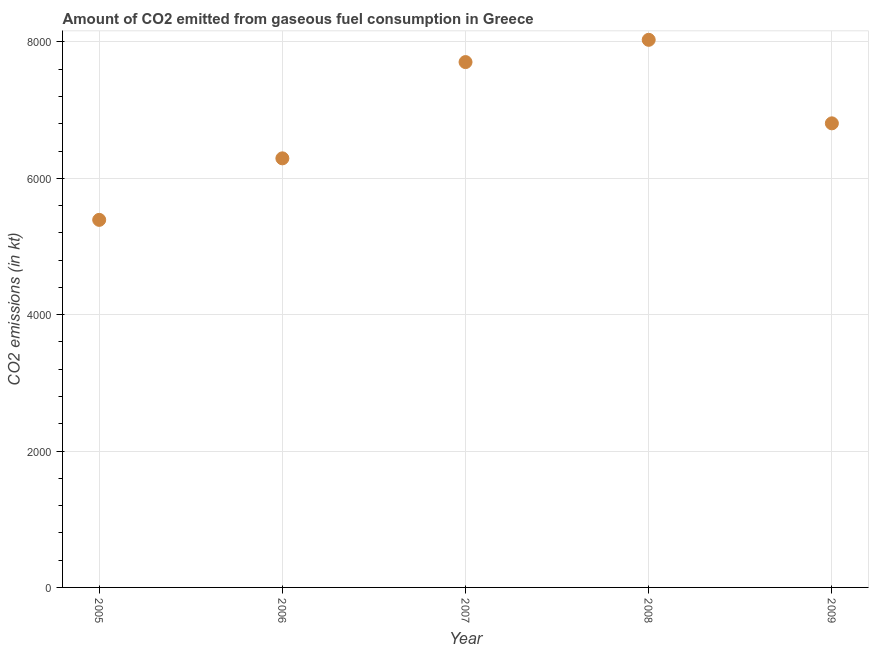What is the co2 emissions from gaseous fuel consumption in 2008?
Ensure brevity in your answer.  8030.73. Across all years, what is the maximum co2 emissions from gaseous fuel consumption?
Provide a short and direct response. 8030.73. Across all years, what is the minimum co2 emissions from gaseous fuel consumption?
Your response must be concise. 5390.49. In which year was the co2 emissions from gaseous fuel consumption maximum?
Offer a very short reply. 2008. What is the sum of the co2 emissions from gaseous fuel consumption?
Offer a terse response. 3.42e+04. What is the difference between the co2 emissions from gaseous fuel consumption in 2005 and 2006?
Provide a succinct answer. -902.08. What is the average co2 emissions from gaseous fuel consumption per year?
Offer a terse response. 6844.82. What is the median co2 emissions from gaseous fuel consumption?
Offer a very short reply. 6805.95. Do a majority of the years between 2007 and 2006 (inclusive) have co2 emissions from gaseous fuel consumption greater than 3600 kt?
Keep it short and to the point. No. What is the ratio of the co2 emissions from gaseous fuel consumption in 2006 to that in 2009?
Your answer should be very brief. 0.92. Is the co2 emissions from gaseous fuel consumption in 2007 less than that in 2009?
Offer a terse response. No. Is the difference between the co2 emissions from gaseous fuel consumption in 2005 and 2006 greater than the difference between any two years?
Offer a terse response. No. What is the difference between the highest and the second highest co2 emissions from gaseous fuel consumption?
Offer a very short reply. 326.36. Is the sum of the co2 emissions from gaseous fuel consumption in 2005 and 2007 greater than the maximum co2 emissions from gaseous fuel consumption across all years?
Keep it short and to the point. Yes. What is the difference between the highest and the lowest co2 emissions from gaseous fuel consumption?
Keep it short and to the point. 2640.24. Does the co2 emissions from gaseous fuel consumption monotonically increase over the years?
Keep it short and to the point. No. How many dotlines are there?
Offer a very short reply. 1. What is the difference between two consecutive major ticks on the Y-axis?
Offer a very short reply. 2000. Are the values on the major ticks of Y-axis written in scientific E-notation?
Provide a succinct answer. No. Does the graph contain grids?
Your answer should be compact. Yes. What is the title of the graph?
Keep it short and to the point. Amount of CO2 emitted from gaseous fuel consumption in Greece. What is the label or title of the X-axis?
Ensure brevity in your answer.  Year. What is the label or title of the Y-axis?
Your answer should be very brief. CO2 emissions (in kt). What is the CO2 emissions (in kt) in 2005?
Provide a short and direct response. 5390.49. What is the CO2 emissions (in kt) in 2006?
Offer a very short reply. 6292.57. What is the CO2 emissions (in kt) in 2007?
Provide a succinct answer. 7704.37. What is the CO2 emissions (in kt) in 2008?
Provide a succinct answer. 8030.73. What is the CO2 emissions (in kt) in 2009?
Offer a very short reply. 6805.95. What is the difference between the CO2 emissions (in kt) in 2005 and 2006?
Your answer should be compact. -902.08. What is the difference between the CO2 emissions (in kt) in 2005 and 2007?
Keep it short and to the point. -2313.88. What is the difference between the CO2 emissions (in kt) in 2005 and 2008?
Offer a terse response. -2640.24. What is the difference between the CO2 emissions (in kt) in 2005 and 2009?
Provide a short and direct response. -1415.46. What is the difference between the CO2 emissions (in kt) in 2006 and 2007?
Ensure brevity in your answer.  -1411.8. What is the difference between the CO2 emissions (in kt) in 2006 and 2008?
Your answer should be very brief. -1738.16. What is the difference between the CO2 emissions (in kt) in 2006 and 2009?
Offer a terse response. -513.38. What is the difference between the CO2 emissions (in kt) in 2007 and 2008?
Ensure brevity in your answer.  -326.36. What is the difference between the CO2 emissions (in kt) in 2007 and 2009?
Offer a very short reply. 898.41. What is the difference between the CO2 emissions (in kt) in 2008 and 2009?
Provide a succinct answer. 1224.78. What is the ratio of the CO2 emissions (in kt) in 2005 to that in 2006?
Make the answer very short. 0.86. What is the ratio of the CO2 emissions (in kt) in 2005 to that in 2007?
Ensure brevity in your answer.  0.7. What is the ratio of the CO2 emissions (in kt) in 2005 to that in 2008?
Offer a very short reply. 0.67. What is the ratio of the CO2 emissions (in kt) in 2005 to that in 2009?
Your response must be concise. 0.79. What is the ratio of the CO2 emissions (in kt) in 2006 to that in 2007?
Keep it short and to the point. 0.82. What is the ratio of the CO2 emissions (in kt) in 2006 to that in 2008?
Offer a terse response. 0.78. What is the ratio of the CO2 emissions (in kt) in 2006 to that in 2009?
Give a very brief answer. 0.93. What is the ratio of the CO2 emissions (in kt) in 2007 to that in 2009?
Your answer should be compact. 1.13. What is the ratio of the CO2 emissions (in kt) in 2008 to that in 2009?
Keep it short and to the point. 1.18. 